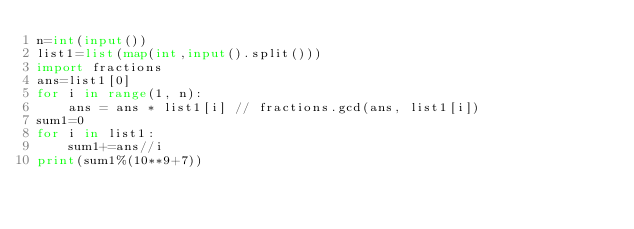<code> <loc_0><loc_0><loc_500><loc_500><_Python_>n=int(input())
list1=list(map(int,input().split()))
import fractions
ans=list1[0]
for i in range(1, n):
    ans = ans * list1[i] // fractions.gcd(ans, list1[i])
sum1=0
for i in list1:
    sum1+=ans//i
print(sum1%(10**9+7))</code> 